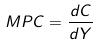Convert formula to latex. <formula><loc_0><loc_0><loc_500><loc_500>M P C = \frac { d C } { d Y }</formula> 